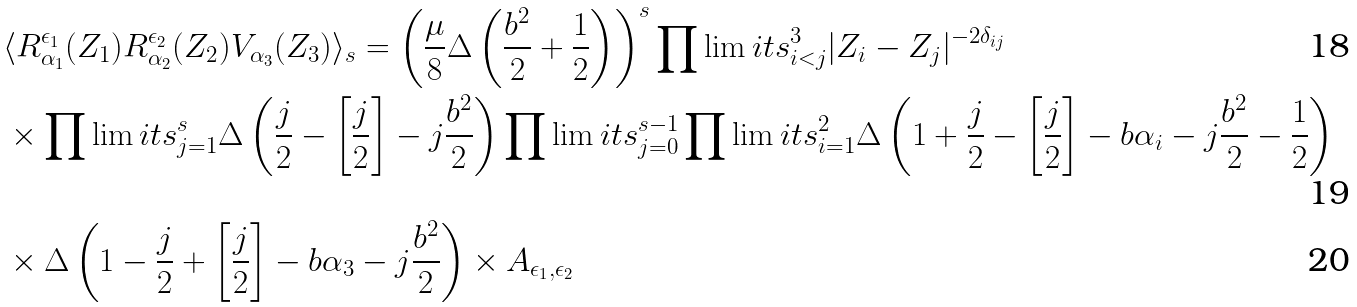<formula> <loc_0><loc_0><loc_500><loc_500>& \langle R ^ { \epsilon _ { 1 } } _ { \alpha _ { 1 } } ( Z _ { 1 } ) R ^ { \epsilon _ { 2 } } _ { \alpha _ { 2 } } ( Z _ { 2 } ) V _ { \alpha _ { 3 } } ( Z _ { 3 } ) \rangle _ { s } = \left ( \frac { \mu } { 8 } \Delta \left ( \frac { b ^ { 2 } } { 2 } + \frac { 1 } { 2 } \right ) \right ) ^ { s } \prod \lim i t s _ { i < j } ^ { 3 } | Z _ { i } - Z _ { j } | ^ { - 2 \delta _ { i j } } \\ & \times \prod \lim i t s _ { j = 1 } ^ { s } \Delta \left ( \frac { j } { 2 } - \left [ \frac { j } { 2 } \right ] - j \frac { b ^ { 2 } } { 2 } \right ) \prod \lim i t s _ { j = 0 } ^ { s - 1 } \prod \lim i t s _ { i = 1 } ^ { 2 } \Delta \left ( 1 + \frac { j } { 2 } - \left [ \frac { j } { 2 } \right ] - b \alpha _ { i } - j \frac { b ^ { 2 } } { 2 } - \frac { 1 } { 2 } \right ) \\ & \times \Delta \left ( 1 - \frac { j } { 2 } + \left [ \frac { j } { 2 } \right ] - b \alpha _ { 3 } - j \frac { b ^ { 2 } } { 2 } \right ) \times A _ { \epsilon _ { 1 } , \epsilon _ { 2 } }</formula> 